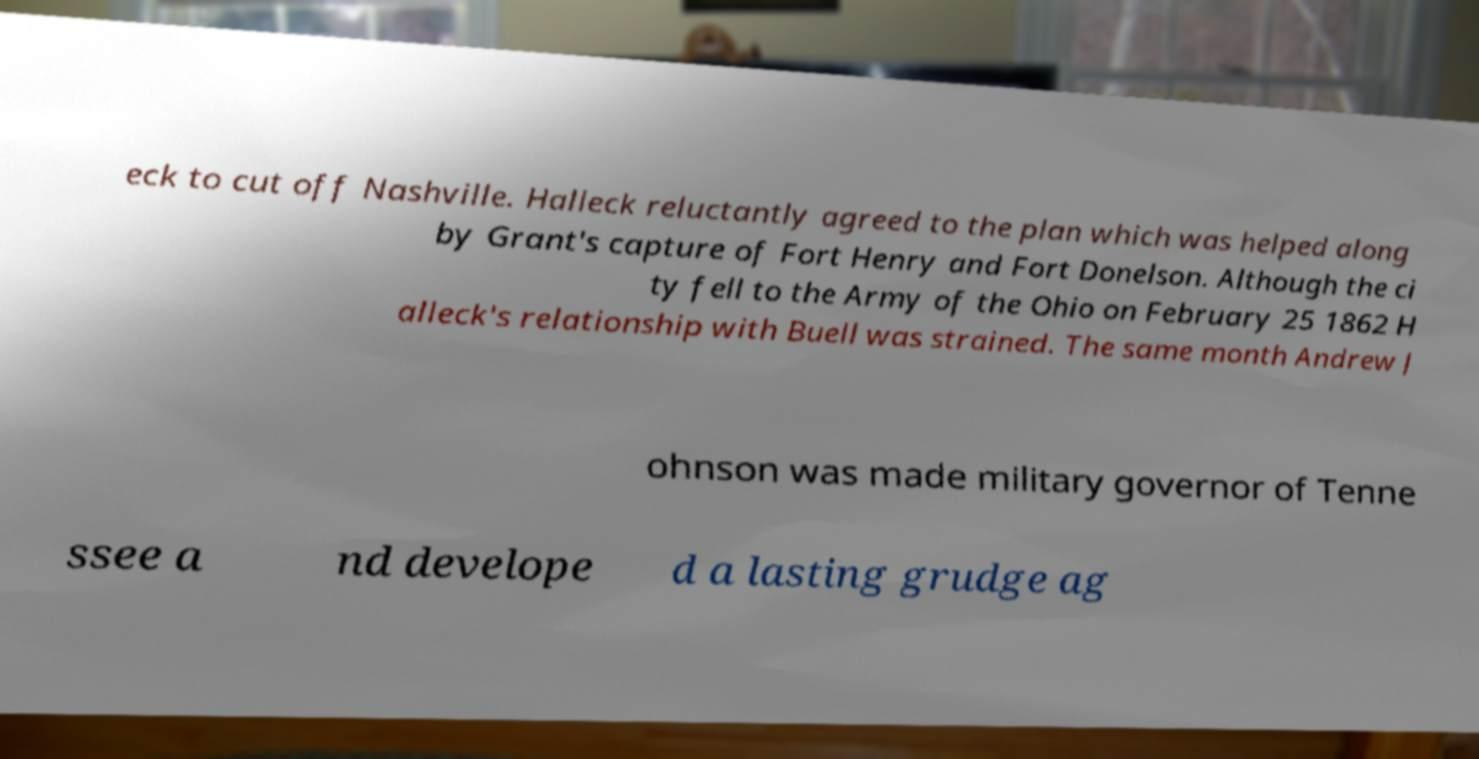I need the written content from this picture converted into text. Can you do that? eck to cut off Nashville. Halleck reluctantly agreed to the plan which was helped along by Grant's capture of Fort Henry and Fort Donelson. Although the ci ty fell to the Army of the Ohio on February 25 1862 H alleck's relationship with Buell was strained. The same month Andrew J ohnson was made military governor of Tenne ssee a nd develope d a lasting grudge ag 